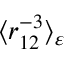Convert formula to latex. <formula><loc_0><loc_0><loc_500><loc_500>\langle r _ { 1 2 } ^ { - 3 } \rangle _ { \varepsilon }</formula> 